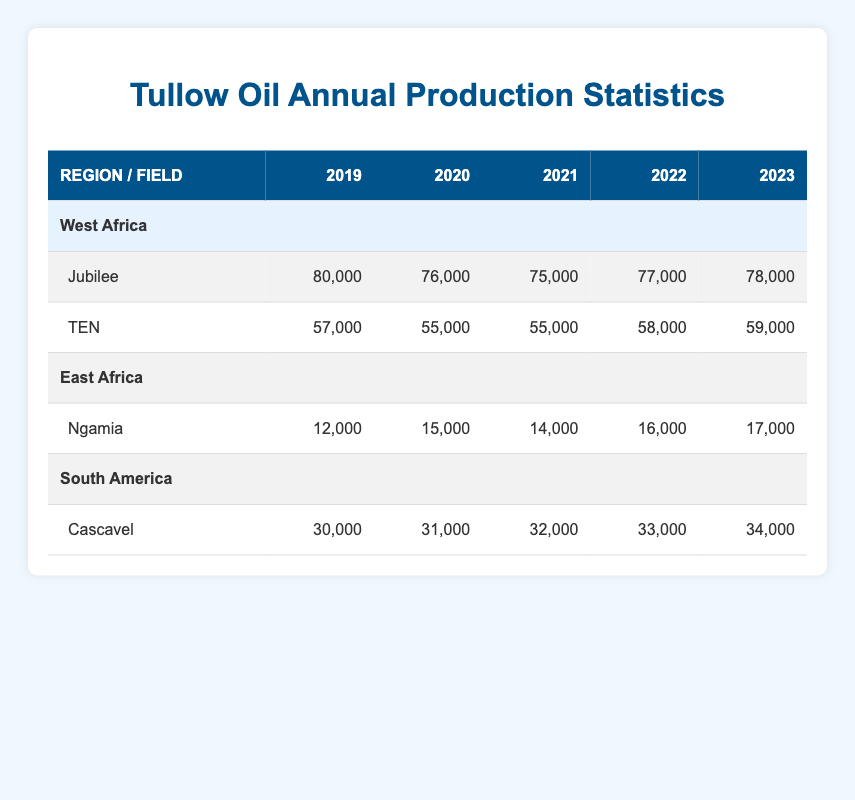What was the production of the Jubilee field in 2021? The table indicates the production for the Jubilee field in the year 2021, which shows a value of 75,000.
Answer: 75,000 Which region had the highest production in 2022? In 2022, West Africa's Jubilee field produced 77,000, TEN produced 58,000, East Africa's Ngamia produced 16,000, and South America's Cascavel produced 33,000. Thus, the highest production in 2022 was from Jubilee in West Africa with 77,000.
Answer: West Africa What is the total production of the TEN field over the last five years? The production values for the TEN field from 2019 to 2023 are: 57,000 + 55,000 + 55,000 + 58,000 + 59,000. Summing these values gives a total of 284,000 for the five years.
Answer: 284,000 Did the production of Ngamia field increase every year from 2019 to 2023? The production values for the Ngamia field were 12,000 in 2019, 15,000 in 2020, 14,000 in 2021, 16,000 in 2022, and 17,000 in 2023. The production increased in 2020, decreased in 2021, and then increased again in the subsequent years; therefore, it did not increase every year.
Answer: No What is the average production of the Cascavel field over the last five years? The production values for Cascavel from 2019 to 2023 are 30,000, 31,000, 32,000, 33,000, and 34,000. To find the average, sum these values (30,000 + 31,000 + 32,000 + 33,000 + 34,000 = 160,000) and divide by 5, resulting in an average of 32,000.
Answer: 32,000 Which field had the lowest production in 2020? In 2020, the Jubilee field produced 76,000, TEN produced 55,000, Ngamia produced 15,000, and Cascavel produced 31,000. The lowest production in 2020 was from the TEN field with 55,000.
Answer: TEN What is the percentage increase in production of the Jubilee field from 2019 to 2023? The production of the Jubilee field in 2019 was 80,000 and in 2023 it was 78,000. The change is 78,000 - 80,000 = -2,000. The percentage increase is calculated as (Change/Old Value)*100 = (-2,000/80,000)*100 = -2.5%. Thus, it is a decrease of 2.5%.
Answer: -2.5% How much did production from the East Africa region change from 2020 to 2023? In 2020, the Ngamia field produced 15,000 and in 2023 it produced 17,000. The change is calculated as 17,000 - 15,000 = 2,000, indicating an increase.
Answer: 2,000 increase 